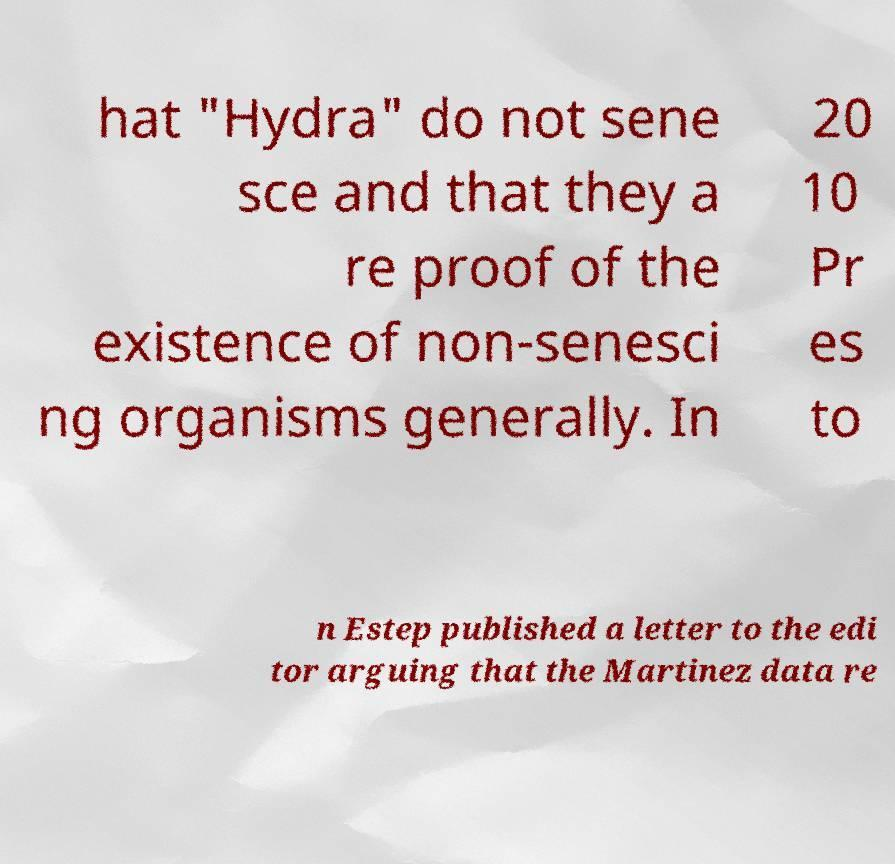There's text embedded in this image that I need extracted. Can you transcribe it verbatim? hat "Hydra" do not sene sce and that they a re proof of the existence of non-senesci ng organisms generally. In 20 10 Pr es to n Estep published a letter to the edi tor arguing that the Martinez data re 